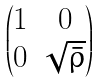Convert formula to latex. <formula><loc_0><loc_0><loc_500><loc_500>\begin{pmatrix} 1 & 0 \\ 0 & \sqrt { \bar { \rho } } \end{pmatrix}</formula> 